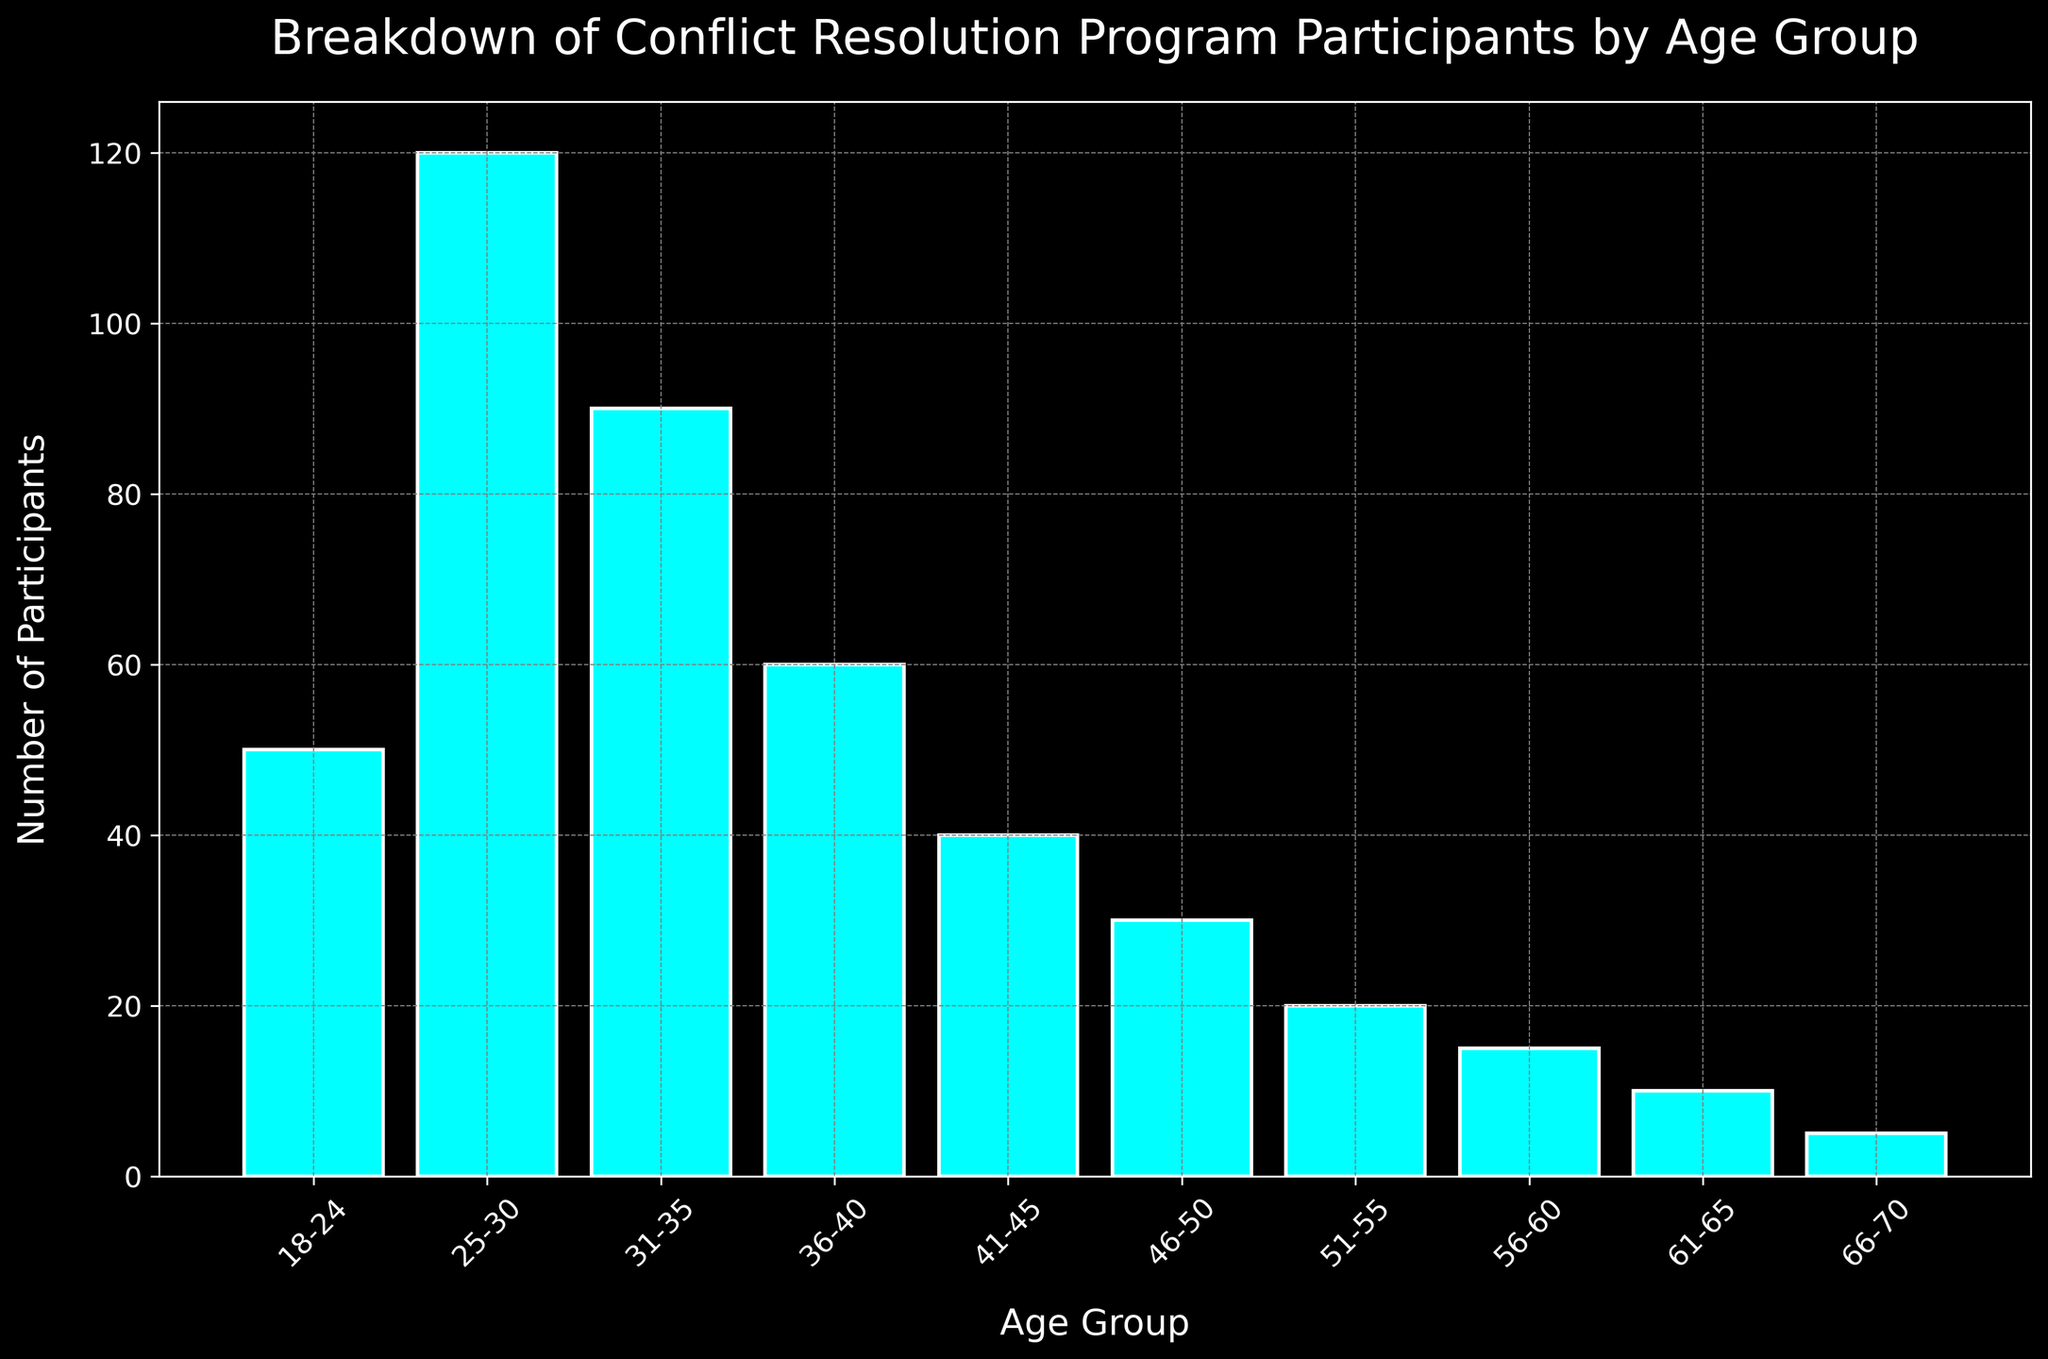What's the age group with the highest number of participants? By observing the heights of the bars in the histogram, the 25-30 age group has the tallest bar, indicating the highest number of participants.
Answer: 25-30 Which age group has the lowest number of participants? The histogram shows that the bar for the 66-70 age group is the shortest, indicating the lowest number of participants.
Answer: 66-70 How many participants are there in the 31-35 and 36-40 age groups combined? Summing the counts for the 31-35 and 36-40 age groups, 90 (31-35) + 60 (36-40) = 150 participants.
Answer: 150 What is the difference in the number of participants between the 18-24 and 46-50 age groups? Subtracting the number of participants in the 46-50 age group (30) from the 18-24 age group (50), the difference is 50 - 30 = 20 participants.
Answer: 20 Which two consecutive age groups have the largest difference in the number of participants? By comparing the differences between consecutive age groups, the largest difference is between the 24-30 age group (120) and the 18-24 age group (50), with a difference of 120 - 50 = 70 participants.
Answer: 18-24 and 25-30 What is the average number of participants in the age groups 41-45 and 46-50? Summing the counts for the 41-45 (40) and 46-50 (30) age groups and then dividing by 2: (40 + 30) / 2 = 35 participants.
Answer: 35 Which age group has more participants, 31-35 or 36-40? By comparing the heights of the bars, the 31-35 age group (90) has more participants than the 36-40 age group (60).
Answer: 31-35 What is the total number of participants in all the age groups combined? Summing the count values for all age groups: 50 + 120 + 90 + 60 + 40 + 30 + 20 + 15 + 10 + 5 = 440 participants.
Answer: 440 How many participants are there in the age groups above 50 years old? Summing the counts for the age groups 51-55 (20), 56-60 (15), 61-65 (10), and 66-70 (5): 20 + 15 + 10 + 5 = 50 participants.
Answer: 50 Which age group has a participant count closer to the overall average? The overall average is the total number of participants (440) divided by the number of age groups (10): 440 / 10 = 44 participants. The 41-45 age group has 40 participants, which is closest to 44.
Answer: 41-45 